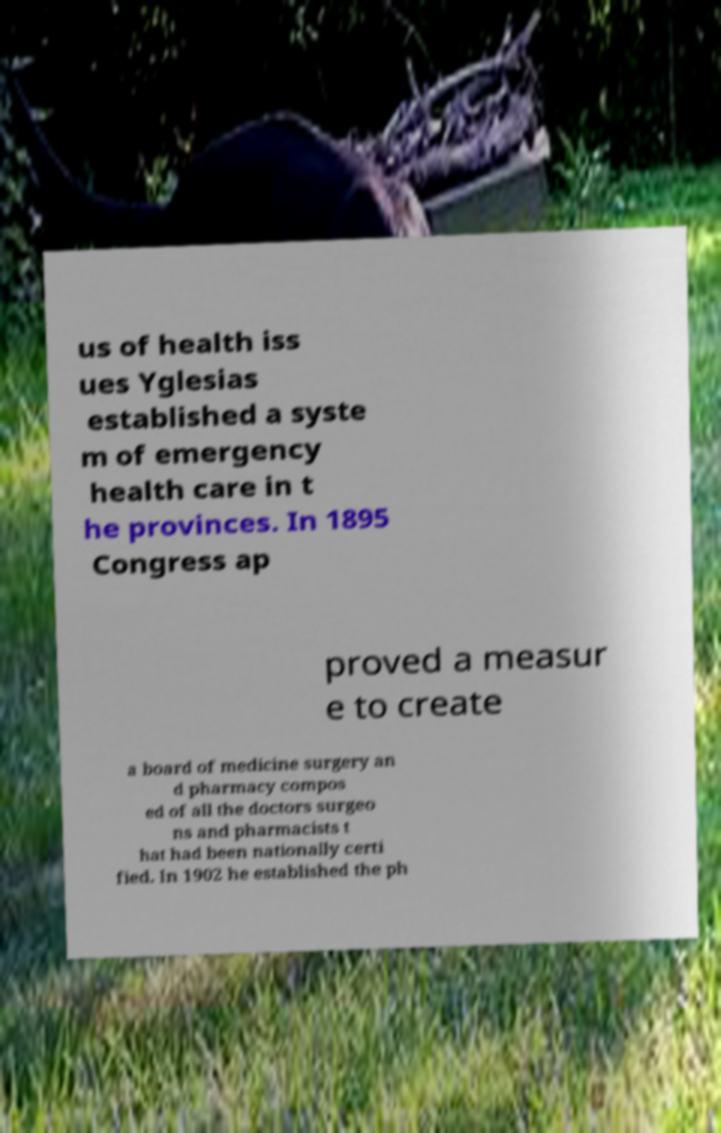What messages or text are displayed in this image? I need them in a readable, typed format. us of health iss ues Yglesias established a syste m of emergency health care in t he provinces. In 1895 Congress ap proved a measur e to create a board of medicine surgery an d pharmacy compos ed of all the doctors surgeo ns and pharmacists t hat had been nationally certi fied. In 1902 he established the ph 